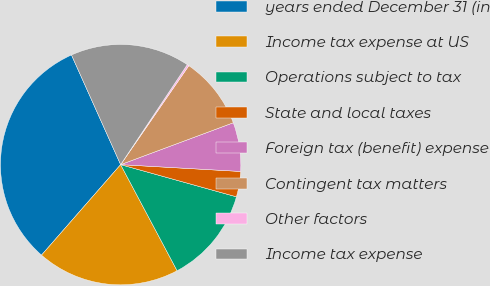Convert chart to OTSL. <chart><loc_0><loc_0><loc_500><loc_500><pie_chart><fcel>years ended December 31 (in<fcel>Income tax expense at US<fcel>Operations subject to tax<fcel>State and local taxes<fcel>Foreign tax (benefit) expense<fcel>Contingent tax matters<fcel>Other factors<fcel>Income tax expense<nl><fcel>31.86%<fcel>19.22%<fcel>12.9%<fcel>3.41%<fcel>6.57%<fcel>9.73%<fcel>0.25%<fcel>16.06%<nl></chart> 